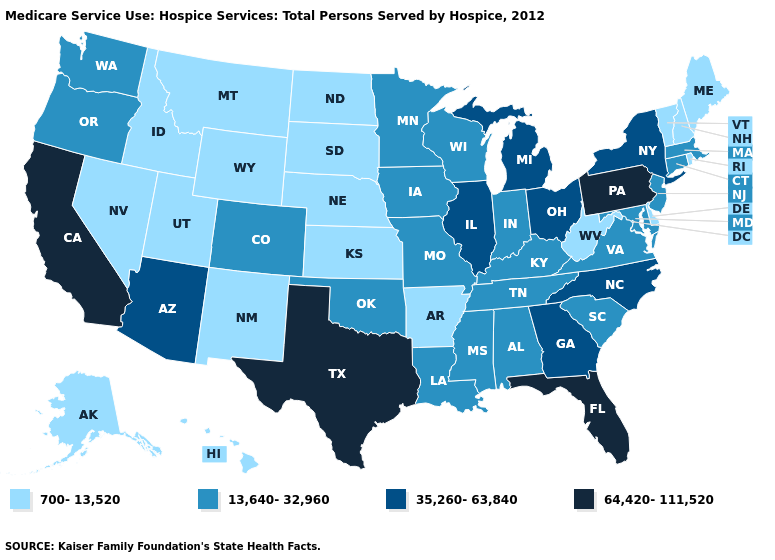Name the states that have a value in the range 64,420-111,520?
Concise answer only. California, Florida, Pennsylvania, Texas. Among the states that border Wisconsin , does Iowa have the lowest value?
Write a very short answer. Yes. What is the value of Idaho?
Be succinct. 700-13,520. Does Nebraska have the lowest value in the MidWest?
Write a very short answer. Yes. What is the value of Ohio?
Concise answer only. 35,260-63,840. What is the value of Massachusetts?
Give a very brief answer. 13,640-32,960. What is the value of Kentucky?
Quick response, please. 13,640-32,960. What is the highest value in the USA?
Write a very short answer. 64,420-111,520. Which states have the lowest value in the USA?
Be succinct. Alaska, Arkansas, Delaware, Hawaii, Idaho, Kansas, Maine, Montana, Nebraska, Nevada, New Hampshire, New Mexico, North Dakota, Rhode Island, South Dakota, Utah, Vermont, West Virginia, Wyoming. What is the value of Delaware?
Answer briefly. 700-13,520. Name the states that have a value in the range 64,420-111,520?
Short answer required. California, Florida, Pennsylvania, Texas. What is the highest value in the West ?
Short answer required. 64,420-111,520. Name the states that have a value in the range 13,640-32,960?
Quick response, please. Alabama, Colorado, Connecticut, Indiana, Iowa, Kentucky, Louisiana, Maryland, Massachusetts, Minnesota, Mississippi, Missouri, New Jersey, Oklahoma, Oregon, South Carolina, Tennessee, Virginia, Washington, Wisconsin. Which states have the highest value in the USA?
Be succinct. California, Florida, Pennsylvania, Texas. What is the value of South Dakota?
Be succinct. 700-13,520. 